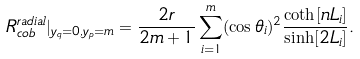Convert formula to latex. <formula><loc_0><loc_0><loc_500><loc_500>R _ { c o b } ^ { r a d i a l } | _ { y _ { q } = 0 , y _ { p } = m } = \frac { 2 r } { 2 m + 1 } \sum _ { i = 1 } ^ { m } ( \cos \theta _ { i } ) ^ { 2 } \frac { \coth [ n L _ { i } ] } { \sinh [ 2 L _ { i } ] } .</formula> 